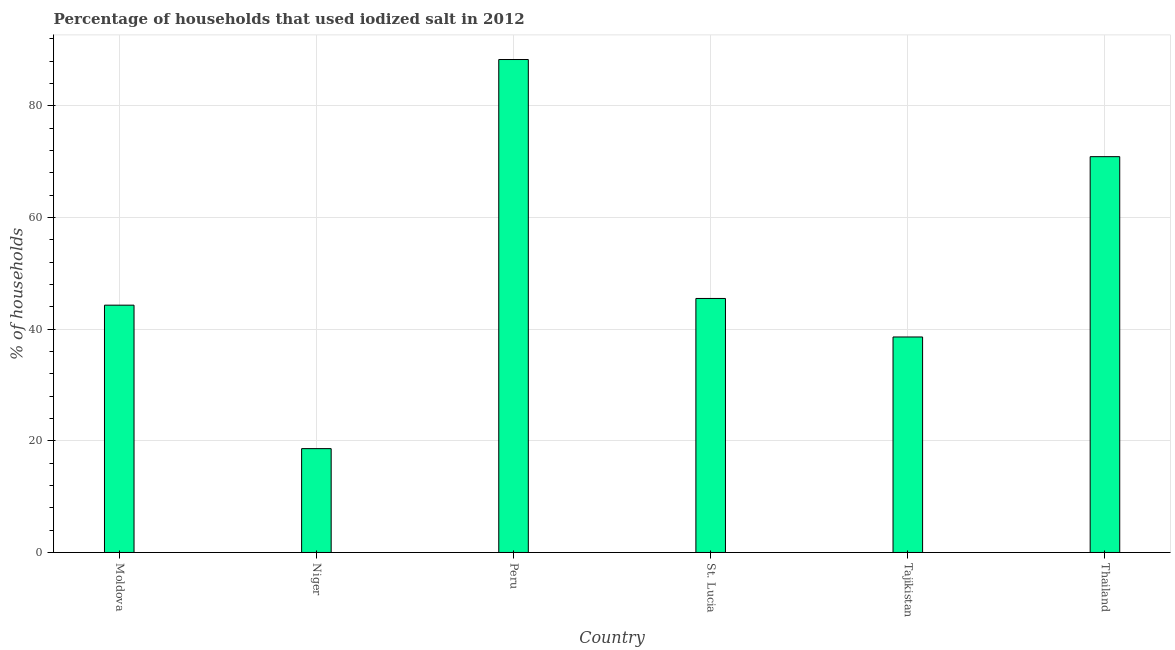What is the title of the graph?
Offer a terse response. Percentage of households that used iodized salt in 2012. What is the label or title of the X-axis?
Your response must be concise. Country. What is the label or title of the Y-axis?
Offer a very short reply. % of households. What is the percentage of households where iodized salt is consumed in Moldova?
Make the answer very short. 44.3. Across all countries, what is the maximum percentage of households where iodized salt is consumed?
Your answer should be compact. 88.3. Across all countries, what is the minimum percentage of households where iodized salt is consumed?
Provide a short and direct response. 18.6. In which country was the percentage of households where iodized salt is consumed maximum?
Provide a short and direct response. Peru. In which country was the percentage of households where iodized salt is consumed minimum?
Your response must be concise. Niger. What is the sum of the percentage of households where iodized salt is consumed?
Your answer should be very brief. 306.2. What is the difference between the percentage of households where iodized salt is consumed in Moldova and Thailand?
Make the answer very short. -26.6. What is the average percentage of households where iodized salt is consumed per country?
Your answer should be very brief. 51.03. What is the median percentage of households where iodized salt is consumed?
Ensure brevity in your answer.  44.9. What is the ratio of the percentage of households where iodized salt is consumed in Moldova to that in Tajikistan?
Your answer should be compact. 1.15. Is the percentage of households where iodized salt is consumed in Moldova less than that in Peru?
Provide a short and direct response. Yes. What is the difference between the highest and the second highest percentage of households where iodized salt is consumed?
Give a very brief answer. 17.4. What is the difference between the highest and the lowest percentage of households where iodized salt is consumed?
Give a very brief answer. 69.7. In how many countries, is the percentage of households where iodized salt is consumed greater than the average percentage of households where iodized salt is consumed taken over all countries?
Your answer should be compact. 2. What is the % of households in Moldova?
Make the answer very short. 44.3. What is the % of households of Niger?
Keep it short and to the point. 18.6. What is the % of households in Peru?
Make the answer very short. 88.3. What is the % of households in St. Lucia?
Your response must be concise. 45.5. What is the % of households of Tajikistan?
Keep it short and to the point. 38.6. What is the % of households of Thailand?
Your response must be concise. 70.9. What is the difference between the % of households in Moldova and Niger?
Make the answer very short. 25.7. What is the difference between the % of households in Moldova and Peru?
Your answer should be compact. -44. What is the difference between the % of households in Moldova and St. Lucia?
Provide a short and direct response. -1.2. What is the difference between the % of households in Moldova and Tajikistan?
Your answer should be compact. 5.7. What is the difference between the % of households in Moldova and Thailand?
Offer a terse response. -26.6. What is the difference between the % of households in Niger and Peru?
Give a very brief answer. -69.7. What is the difference between the % of households in Niger and St. Lucia?
Ensure brevity in your answer.  -26.9. What is the difference between the % of households in Niger and Tajikistan?
Your answer should be compact. -20. What is the difference between the % of households in Niger and Thailand?
Offer a very short reply. -52.3. What is the difference between the % of households in Peru and St. Lucia?
Provide a short and direct response. 42.8. What is the difference between the % of households in Peru and Tajikistan?
Keep it short and to the point. 49.7. What is the difference between the % of households in Peru and Thailand?
Keep it short and to the point. 17.4. What is the difference between the % of households in St. Lucia and Thailand?
Provide a succinct answer. -25.4. What is the difference between the % of households in Tajikistan and Thailand?
Provide a short and direct response. -32.3. What is the ratio of the % of households in Moldova to that in Niger?
Provide a succinct answer. 2.38. What is the ratio of the % of households in Moldova to that in Peru?
Ensure brevity in your answer.  0.5. What is the ratio of the % of households in Moldova to that in Tajikistan?
Give a very brief answer. 1.15. What is the ratio of the % of households in Moldova to that in Thailand?
Offer a very short reply. 0.62. What is the ratio of the % of households in Niger to that in Peru?
Make the answer very short. 0.21. What is the ratio of the % of households in Niger to that in St. Lucia?
Give a very brief answer. 0.41. What is the ratio of the % of households in Niger to that in Tajikistan?
Your response must be concise. 0.48. What is the ratio of the % of households in Niger to that in Thailand?
Provide a succinct answer. 0.26. What is the ratio of the % of households in Peru to that in St. Lucia?
Your answer should be compact. 1.94. What is the ratio of the % of households in Peru to that in Tajikistan?
Your answer should be compact. 2.29. What is the ratio of the % of households in Peru to that in Thailand?
Keep it short and to the point. 1.25. What is the ratio of the % of households in St. Lucia to that in Tajikistan?
Make the answer very short. 1.18. What is the ratio of the % of households in St. Lucia to that in Thailand?
Offer a very short reply. 0.64. What is the ratio of the % of households in Tajikistan to that in Thailand?
Offer a very short reply. 0.54. 